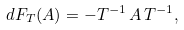Convert formula to latex. <formula><loc_0><loc_0><loc_500><loc_500>d F _ { T } ( A ) = - T ^ { - 1 } \, A \, T ^ { - 1 } ,</formula> 